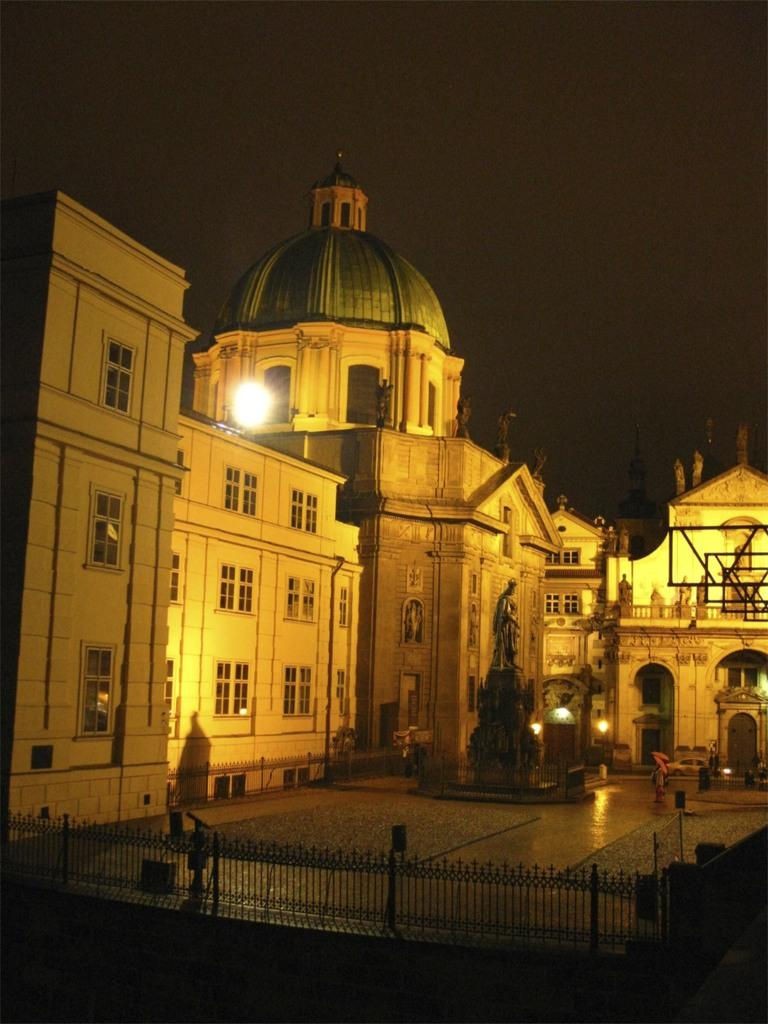What can be seen in the image that might be used for support or safety? There is a railing in the image that might be used for support or safety. What type of structure can be seen in the background of the image? There is a building in the background of the image. What can be seen in the image that provides illumination? There are lights visible in the image. What is the color of the sky in the image? The sky appears to be black in color in the image. Can you see a woman holding a note and a balloon in the image? No, there is no woman, note, or balloon present in the image. 